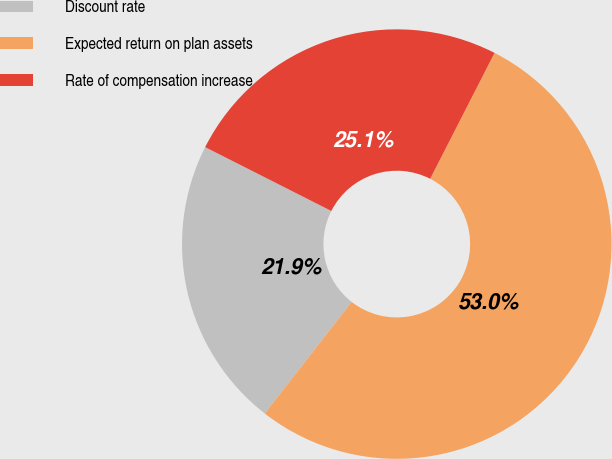Convert chart. <chart><loc_0><loc_0><loc_500><loc_500><pie_chart><fcel>Discount rate<fcel>Expected return on plan assets<fcel>Rate of compensation increase<nl><fcel>21.92%<fcel>53.01%<fcel>25.07%<nl></chart> 